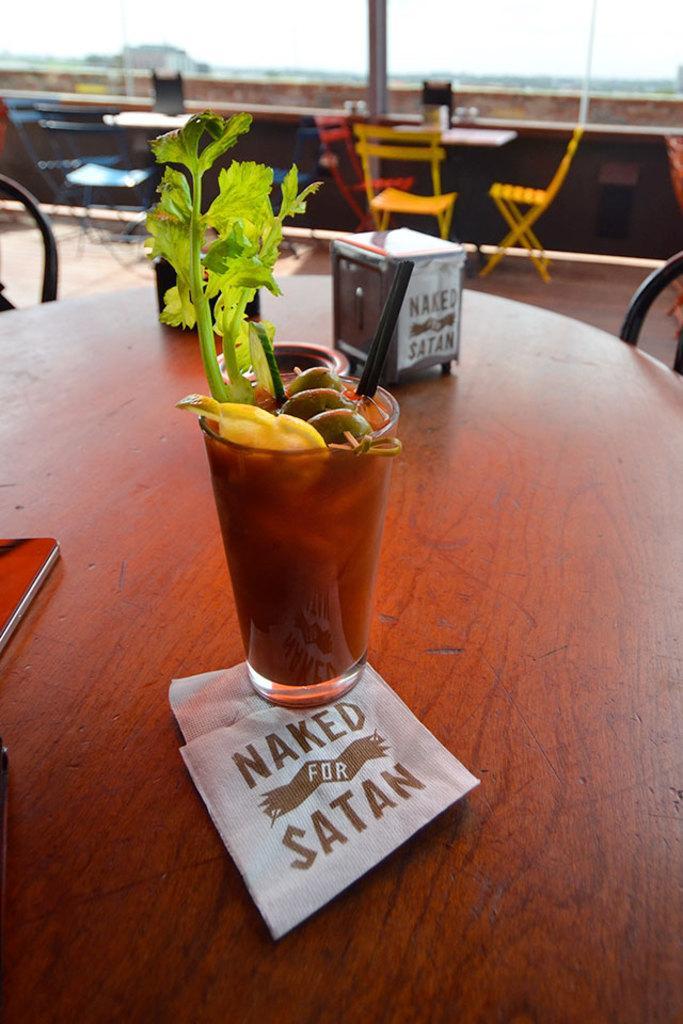Could you give a brief overview of what you see in this image? In this picture we can see some table, chairs are arranged, on the table we can see some potted plants and papers. 